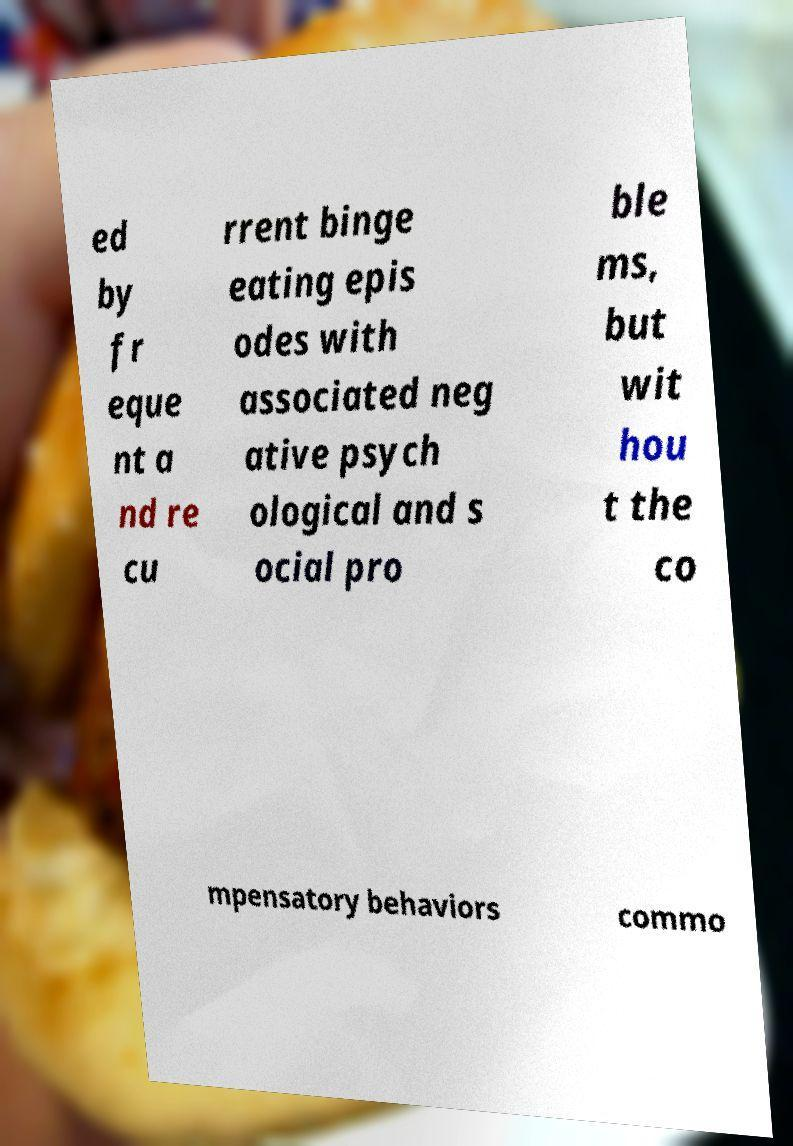Please read and relay the text visible in this image. What does it say? ed by fr eque nt a nd re cu rrent binge eating epis odes with associated neg ative psych ological and s ocial pro ble ms, but wit hou t the co mpensatory behaviors commo 